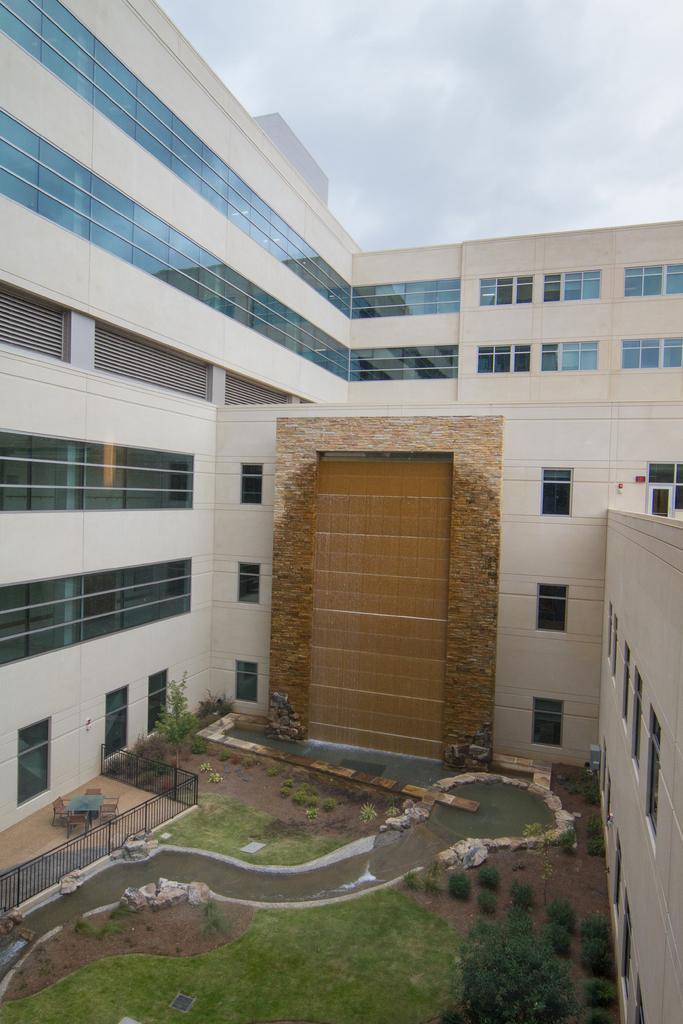Could you give a brief overview of what you see in this image? As we can see in the image there are buildings, windows and trees. There is fence, water, grass and at the top there is sky. 